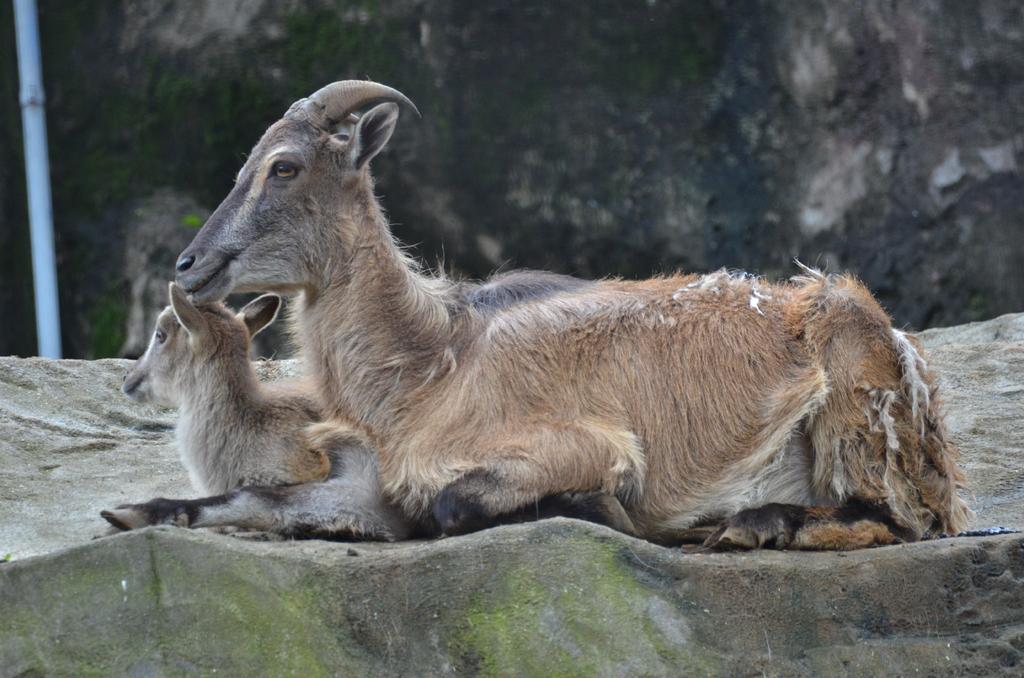Could you give a brief overview of what you see in this image? In this image there are two animals sitting on the rock. 